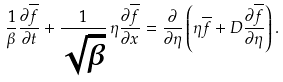<formula> <loc_0><loc_0><loc_500><loc_500>\frac { 1 } { \beta } \frac { \partial \overline { f } } { \partial t } + \frac { 1 } { \sqrt { \beta } } \, \eta \frac { \partial \overline { f } } { \partial x } = \frac { \partial } { \partial \eta } \left ( \eta \overline { f } + D \frac { \partial \overline { f } } { \partial \eta } \right ) .</formula> 